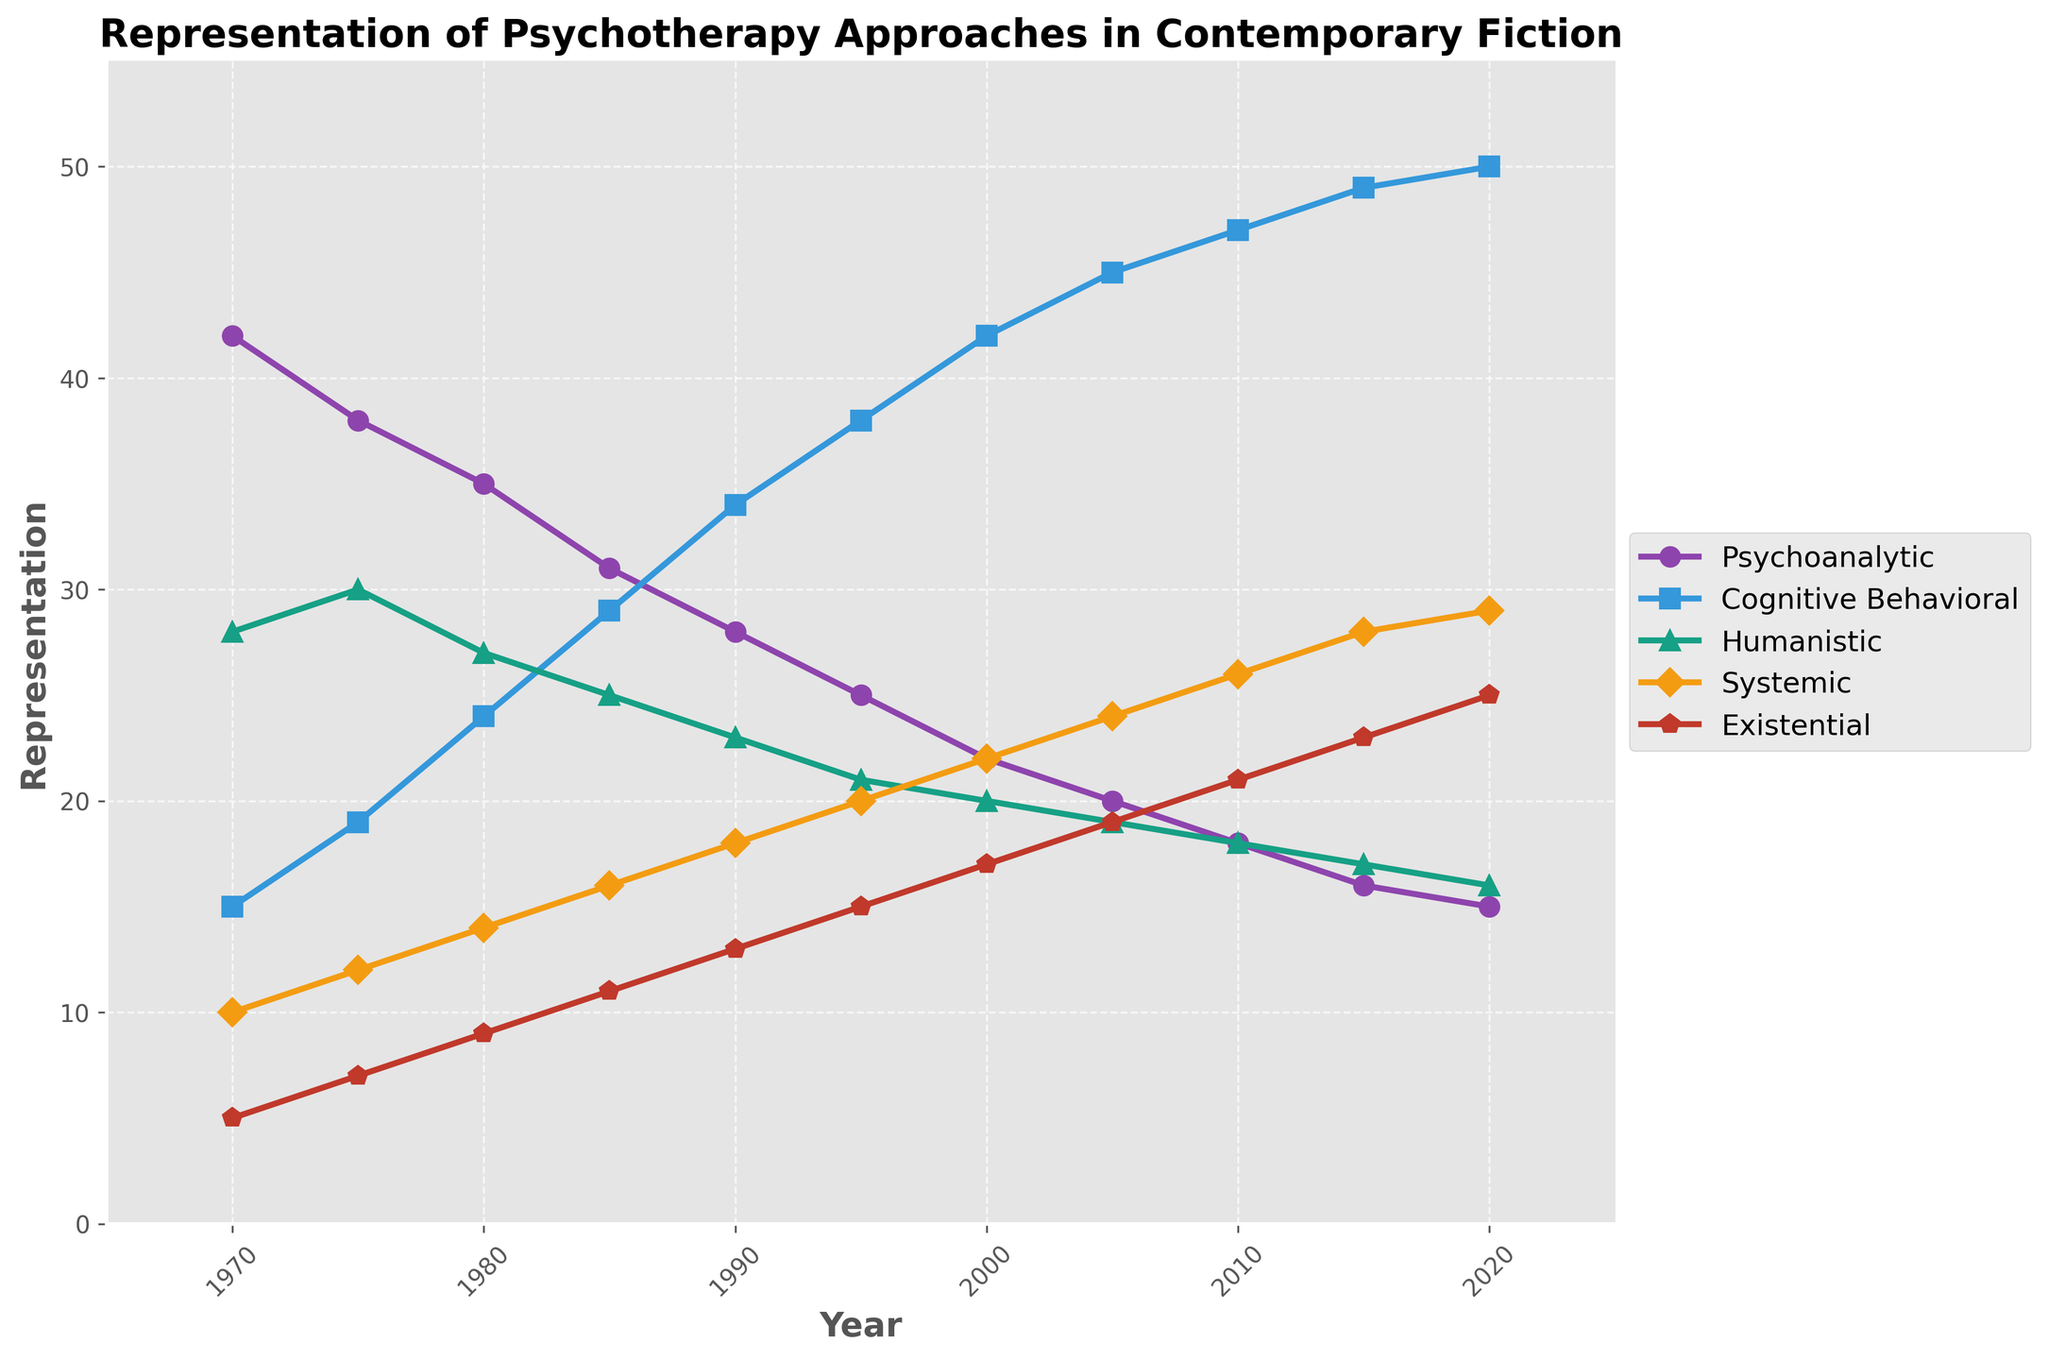What psychotherapy approach had the highest representation in the year 1985? Observing the figure, in 1985, Cognitive Behavioral Therapy intersects the highest point among all approaches.
Answer: Cognitive Behavioral Which psychotherapy approach saw the greatest increase in representation from 1970 to 2020? Comparing the 1970 and 2020 data points for each therapy, Cognitive Behavioral Therapy grew from 15 to 50, the largest increase.
Answer: Cognitive Behavioral Which year had a higher representation of Humanistic therapy, 1980 or 1995? Looking at the chart, Humanistic therapy in 1980 is at 27 and in 1995, it's at 21; hence, higher in 1980.
Answer: 1980 What is the combined representation of Existential and Systemic approaches in 2010? In 2010, the representation values for Existential and Systemic are 21 and 26 respectively. Their combined value is 21 + 26 = 47.
Answer: 47 Did the representation of Psychoanalytic approach ever fall below 20? If yes, in which years? By examining the curves, the representation of Psychoanalytic approach fell below 20 from 2010 until 2020.
Answer: 2010 to 2020 Which psychotherapy approaches showed a declining trend in representation over the 50 years? Only Psychoanalytic therapy consistently declined from 42 in 1970 to 15 in 2020.
Answer: Psychoanalytic What is the difference in the representation of Cognitive Behavioral and Humanistic approaches in 2005? In 2005, Cognitive Behavioral is at 45 and Humanistic at 19. The difference is 45 - 19 = 26.
Answer: 26 Did Humanistic and Existential approaches ever have the same level of representation? If yes, in which year(s)? The chart needs to be inspected for overlapping points; both approaches intersect at representation value of 19 in 2005.
Answer: 2005 Which psychotherapy approach was always less represented than Systemic approach throughout the years? Existential therapy never surpasses Systemic approach from 1970 to 2020.
Answer: Existential 